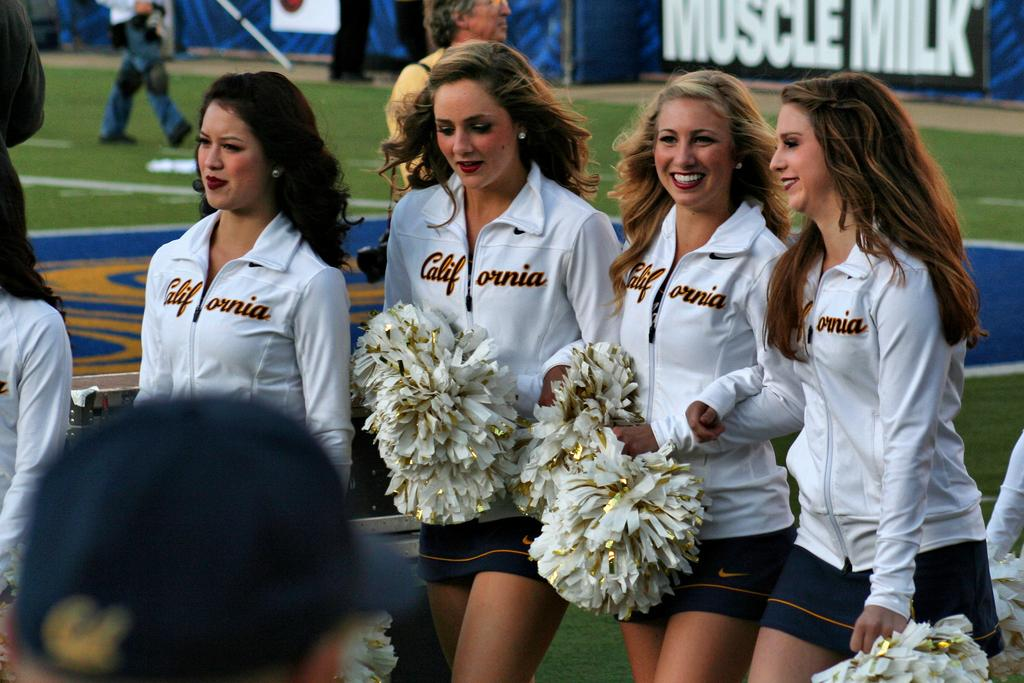<image>
Write a terse but informative summary of the picture. A group of California cheerleaders stand on a field that is sponsored by Muscle Milk. 